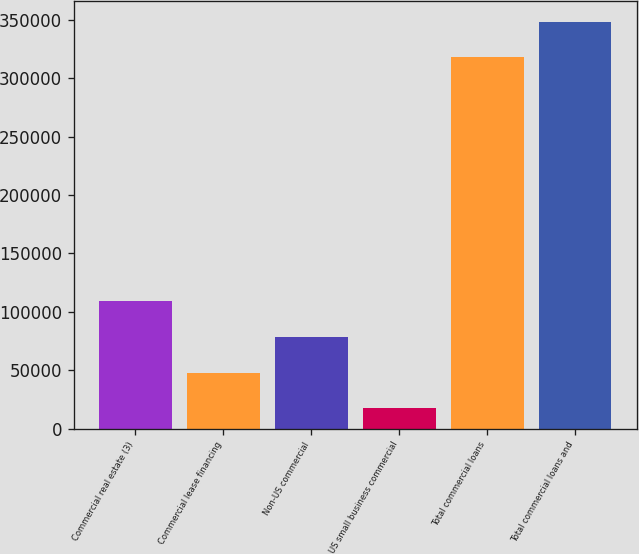Convert chart to OTSL. <chart><loc_0><loc_0><loc_500><loc_500><bar_chart><fcel>Commercial real estate (3)<fcel>Commercial lease financing<fcel>Non-US commercial<fcel>US small business commercial<fcel>Total commercial loans<fcel>Total commercial loans and<nl><fcel>109037<fcel>48029.8<fcel>78533.6<fcel>17526<fcel>317628<fcel>348132<nl></chart> 